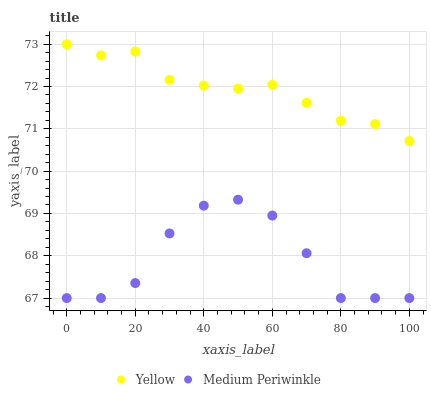Does Medium Periwinkle have the minimum area under the curve?
Answer yes or no. Yes. Does Yellow have the maximum area under the curve?
Answer yes or no. Yes. Does Yellow have the minimum area under the curve?
Answer yes or no. No. Is Yellow the smoothest?
Answer yes or no. Yes. Is Medium Periwinkle the roughest?
Answer yes or no. Yes. Is Yellow the roughest?
Answer yes or no. No. Does Medium Periwinkle have the lowest value?
Answer yes or no. Yes. Does Yellow have the lowest value?
Answer yes or no. No. Does Yellow have the highest value?
Answer yes or no. Yes. Is Medium Periwinkle less than Yellow?
Answer yes or no. Yes. Is Yellow greater than Medium Periwinkle?
Answer yes or no. Yes. Does Medium Periwinkle intersect Yellow?
Answer yes or no. No. 